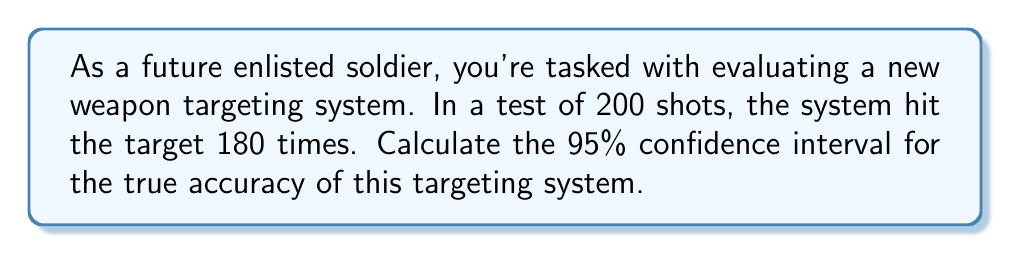Can you answer this question? Let's approach this step-by-step:

1) First, we need to calculate the sample proportion:
   $\hat{p} = \frac{\text{number of successes}}{\text{total number of trials}} = \frac{180}{200} = 0.9$

2) The formula for the confidence interval is:
   $$\hat{p} \pm z_{\alpha/2} \sqrt{\frac{\hat{p}(1-\hat{p})}{n}}$$
   where $z_{\alpha/2}$ is the critical value for the desired confidence level.

3) For a 95% confidence interval, $z_{\alpha/2} = 1.96$

4) Now, let's plug in our values:
   $n = 200$
   $\hat{p} = 0.9$

5) Calculate the standard error:
   $$SE = \sqrt{\frac{\hat{p}(1-\hat{p})}{n}} = \sqrt{\frac{0.9(1-0.9)}{200}} = \sqrt{\frac{0.09}{200}} = 0.0212$$

6) Now we can calculate the margin of error:
   $$ME = 1.96 \times 0.0212 = 0.0416$$

7) Finally, we can calculate the confidence interval:
   $$0.9 \pm 0.0416$$
   
   Lower bound: $0.9 - 0.0416 = 0.8584$
   Upper bound: $0.9 + 0.0416 = 0.9416$

Therefore, we are 95% confident that the true accuracy of the targeting system is between 85.84% and 94.16%.
Answer: (0.8584, 0.9416) or 85.84% to 94.16% 